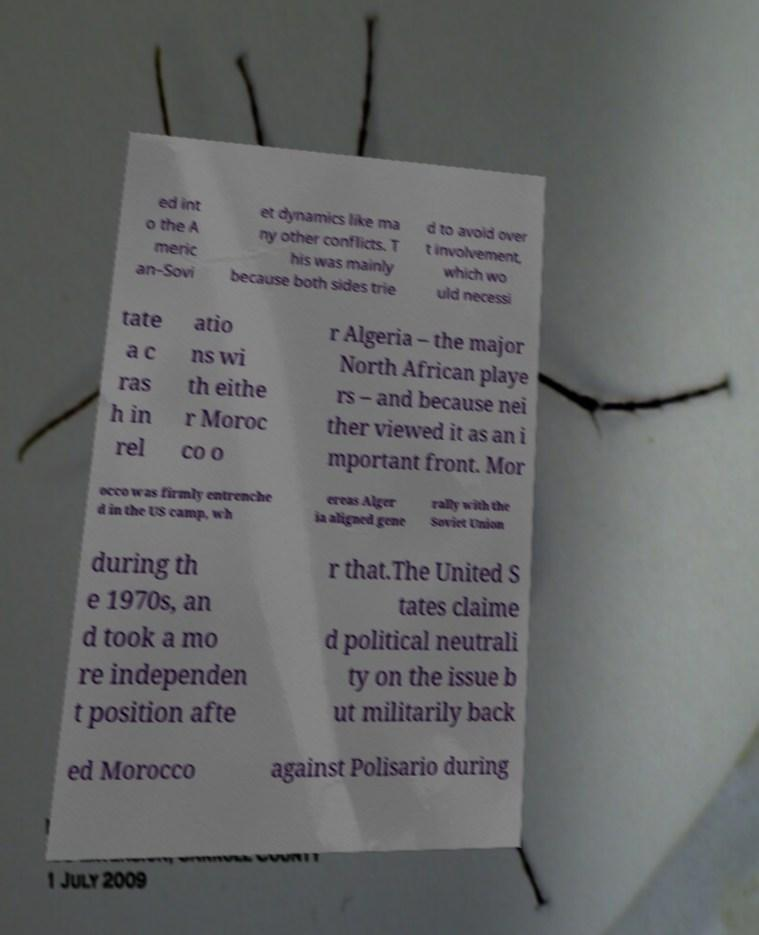For documentation purposes, I need the text within this image transcribed. Could you provide that? ed int o the A meric an–Sovi et dynamics like ma ny other conflicts. T his was mainly because both sides trie d to avoid over t involvement, which wo uld necessi tate a c ras h in rel atio ns wi th eithe r Moroc co o r Algeria – the major North African playe rs – and because nei ther viewed it as an i mportant front. Mor occo was firmly entrenche d in the US camp, wh ereas Alger ia aligned gene rally with the Soviet Union during th e 1970s, an d took a mo re independen t position afte r that.The United S tates claime d political neutrali ty on the issue b ut militarily back ed Morocco against Polisario during 